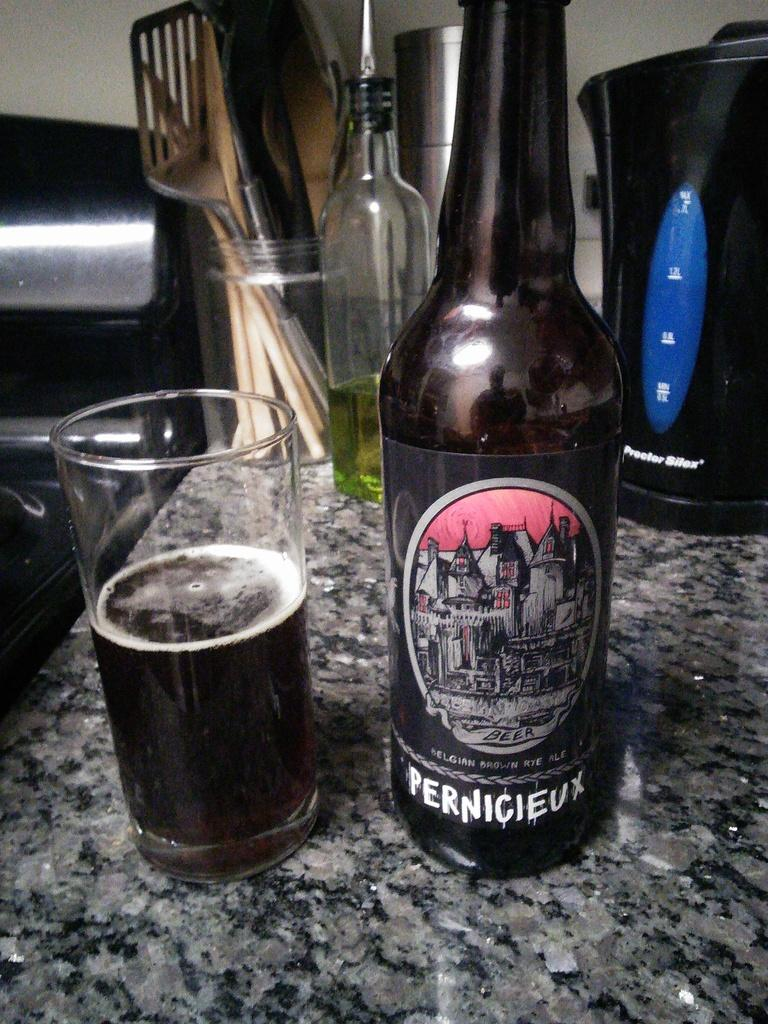<image>
Describe the image concisely. A bottle of Pernicieux is sitting on the counter. 